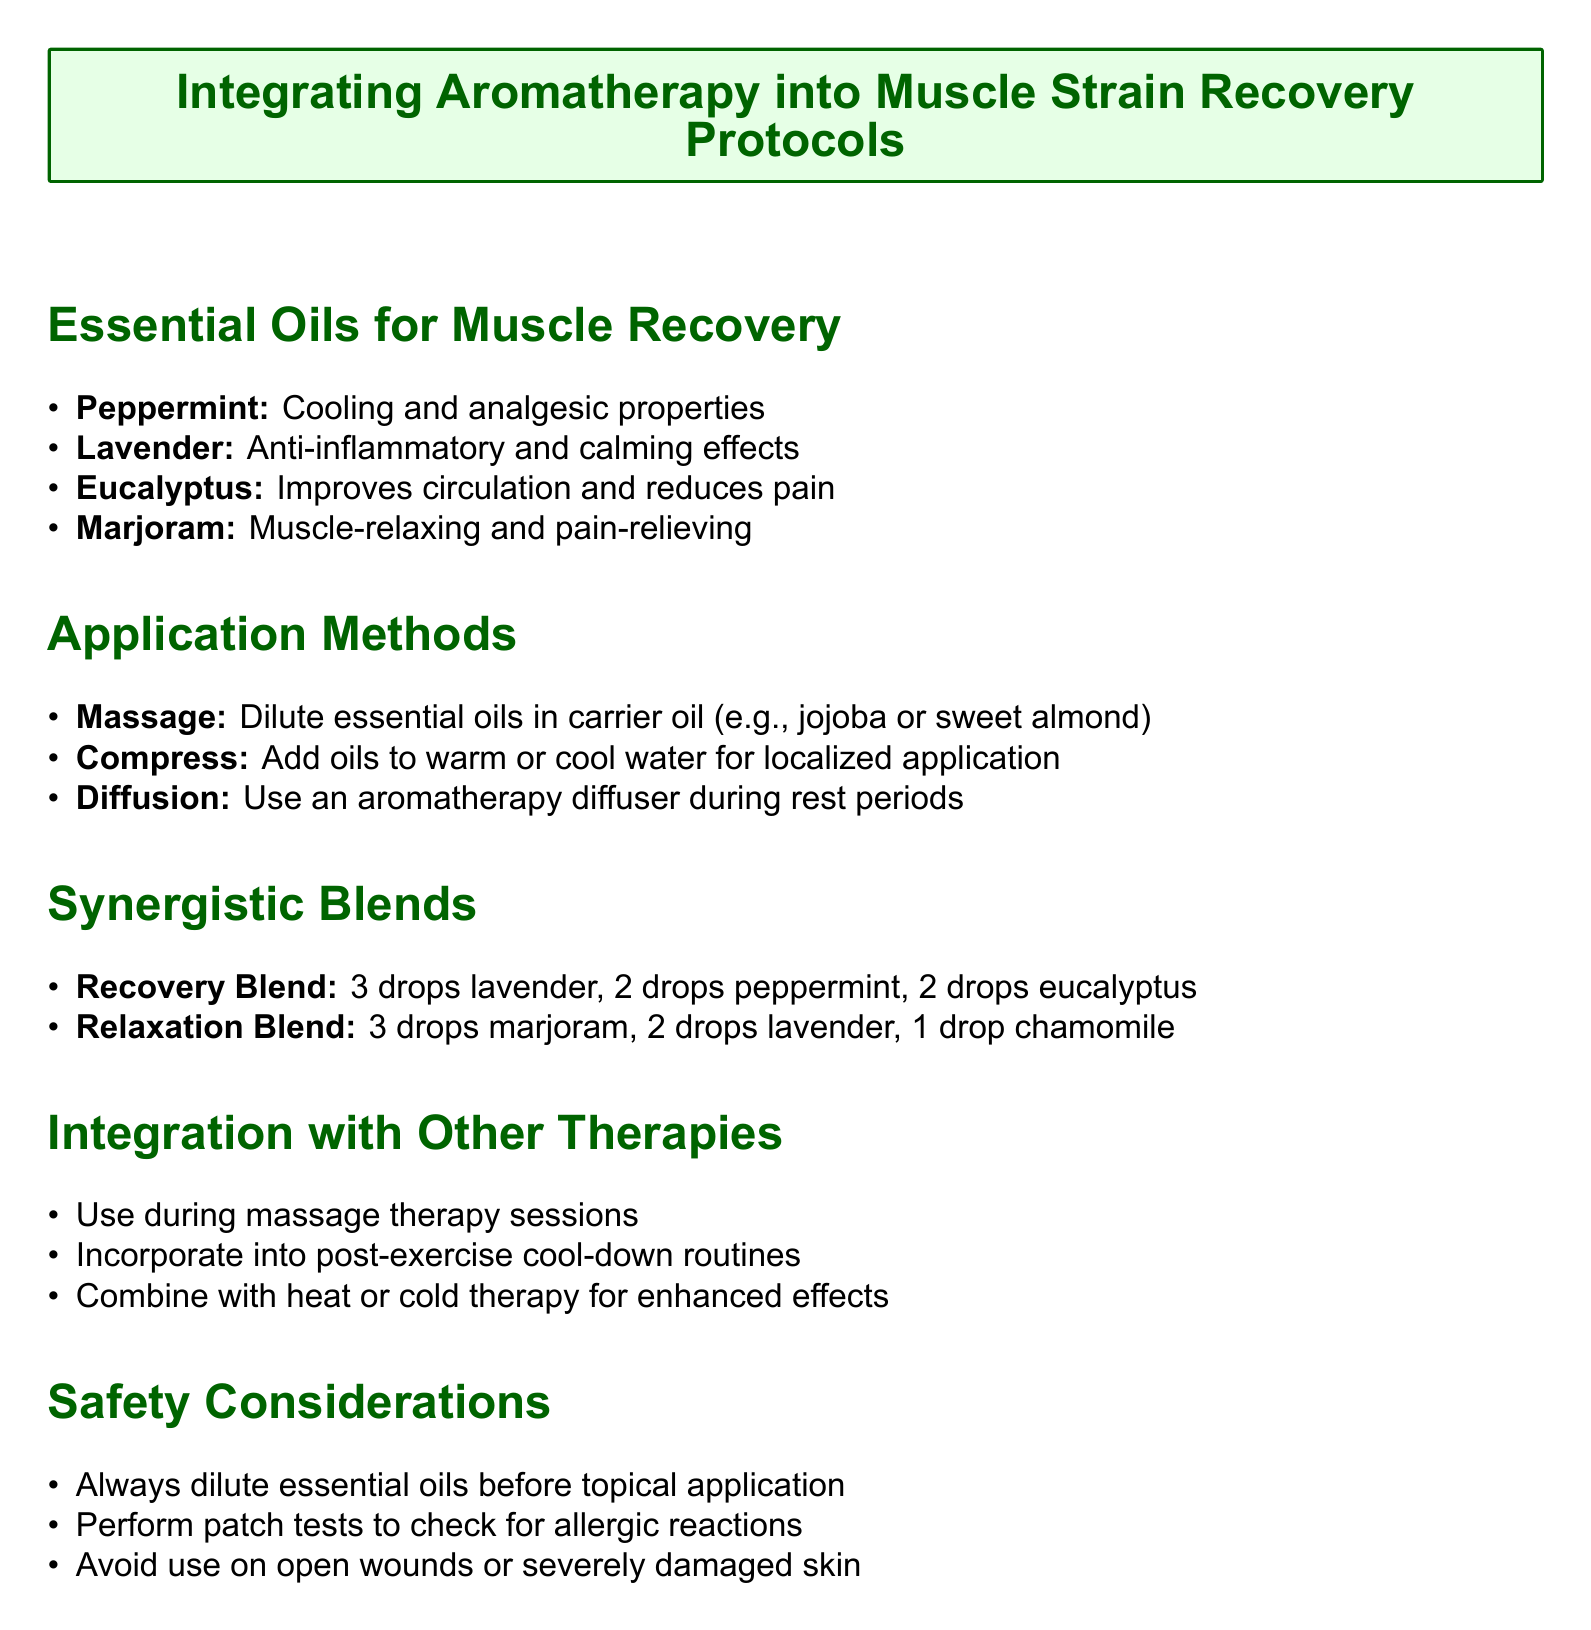What are the properties of peppermint oil? The document lists peppermint oil as having cooling and analgesic properties.
Answer: Cooling and analgesic What is included in the Recovery Blend? The Recovery Blend consists of 3 drops of lavender, 2 drops of peppermint, and 2 drops of eucalyptus.
Answer: 3 drops lavender, 2 drops peppermint, 2 drops eucalyptus What application method uses an aromatherapy diffuser? The application method where an aromatherapy diffuser is used is during rest periods.
Answer: Diffusion What essential oil is known for its calming effects? Lavender is noted in the document for its anti-inflammatory and calming effects.
Answer: Lavender What should be done before applying essential oils topically? The document advises to always dilute essential oils before topical application.
Answer: Dilute What is a safety consideration regarding essential oils? One safety consideration mentioned is to avoid use on open wounds or severely damaged skin.
Answer: Avoid use on open wounds What is marjoram known for? Marjoram is described as muscle-relaxing and pain-relieving.
Answer: Muscle-relaxing and pain-relieving In what routine can aromatherapy be incorporated according to the document? Aromatherapy can be incorporated into post-exercise cool-down routines.
Answer: Post-exercise cool-down routines What carrier oils are suggested for diluting essential oils? The document mentions jojoba or sweet almond as examples of carrier oils.
Answer: Jojoba or sweet almond 